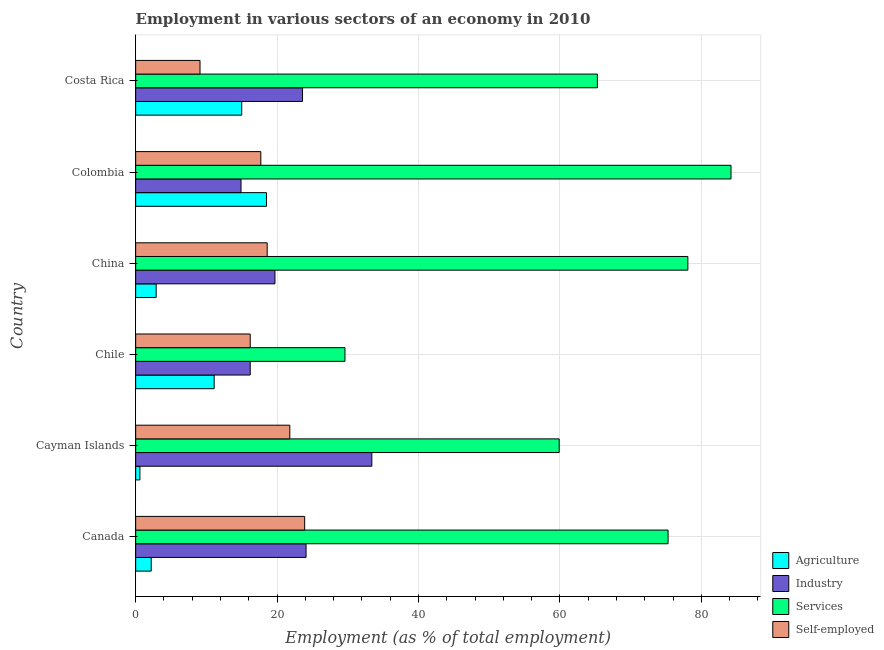How many different coloured bars are there?
Keep it short and to the point. 4. Are the number of bars per tick equal to the number of legend labels?
Provide a short and direct response. Yes. How many bars are there on the 6th tick from the top?
Provide a succinct answer. 4. What is the label of the 1st group of bars from the top?
Your answer should be very brief. Costa Rica. What is the percentage of workers in industry in Chile?
Give a very brief answer. 16.2. Across all countries, what is the maximum percentage of workers in industry?
Your answer should be compact. 33.4. Across all countries, what is the minimum percentage of workers in industry?
Provide a succinct answer. 14.9. In which country was the percentage of workers in services minimum?
Provide a succinct answer. Chile. What is the total percentage of self employed workers in the graph?
Provide a succinct answer. 107.3. What is the difference between the percentage of self employed workers in China and the percentage of workers in agriculture in Canada?
Offer a terse response. 16.4. What is the average percentage of workers in industry per country?
Your response must be concise. 21.98. What is the difference between the percentage of workers in industry and percentage of workers in agriculture in Cayman Islands?
Your answer should be compact. 32.8. What is the ratio of the percentage of self employed workers in China to that in Colombia?
Keep it short and to the point. 1.05. What is the difference between the highest and the lowest percentage of workers in industry?
Ensure brevity in your answer.  18.5. Is it the case that in every country, the sum of the percentage of self employed workers and percentage of workers in industry is greater than the sum of percentage of workers in services and percentage of workers in agriculture?
Offer a very short reply. No. What does the 2nd bar from the top in Canada represents?
Make the answer very short. Services. What does the 2nd bar from the bottom in Colombia represents?
Offer a very short reply. Industry. How many bars are there?
Offer a very short reply. 24. Are all the bars in the graph horizontal?
Your answer should be compact. Yes. What is the difference between two consecutive major ticks on the X-axis?
Your answer should be very brief. 20. Does the graph contain any zero values?
Your answer should be compact. No. Does the graph contain grids?
Offer a very short reply. Yes. What is the title of the graph?
Your answer should be compact. Employment in various sectors of an economy in 2010. Does "Social Awareness" appear as one of the legend labels in the graph?
Ensure brevity in your answer.  No. What is the label or title of the X-axis?
Provide a short and direct response. Employment (as % of total employment). What is the label or title of the Y-axis?
Make the answer very short. Country. What is the Employment (as % of total employment) of Agriculture in Canada?
Offer a very short reply. 2.2. What is the Employment (as % of total employment) in Industry in Canada?
Keep it short and to the point. 24.1. What is the Employment (as % of total employment) of Services in Canada?
Offer a terse response. 75.3. What is the Employment (as % of total employment) of Self-employed in Canada?
Provide a short and direct response. 23.9. What is the Employment (as % of total employment) of Agriculture in Cayman Islands?
Give a very brief answer. 0.6. What is the Employment (as % of total employment) of Industry in Cayman Islands?
Your response must be concise. 33.4. What is the Employment (as % of total employment) in Services in Cayman Islands?
Your answer should be very brief. 59.9. What is the Employment (as % of total employment) in Self-employed in Cayman Islands?
Provide a succinct answer. 21.8. What is the Employment (as % of total employment) of Agriculture in Chile?
Offer a very short reply. 11.1. What is the Employment (as % of total employment) in Industry in Chile?
Make the answer very short. 16.2. What is the Employment (as % of total employment) in Services in Chile?
Keep it short and to the point. 29.6. What is the Employment (as % of total employment) in Self-employed in Chile?
Your answer should be compact. 16.2. What is the Employment (as % of total employment) in Agriculture in China?
Provide a succinct answer. 2.9. What is the Employment (as % of total employment) of Industry in China?
Keep it short and to the point. 19.7. What is the Employment (as % of total employment) of Services in China?
Keep it short and to the point. 78.1. What is the Employment (as % of total employment) in Self-employed in China?
Keep it short and to the point. 18.6. What is the Employment (as % of total employment) of Industry in Colombia?
Offer a very short reply. 14.9. What is the Employment (as % of total employment) of Services in Colombia?
Your answer should be very brief. 84.2. What is the Employment (as % of total employment) of Self-employed in Colombia?
Provide a succinct answer. 17.7. What is the Employment (as % of total employment) of Industry in Costa Rica?
Your response must be concise. 23.6. What is the Employment (as % of total employment) of Services in Costa Rica?
Your response must be concise. 65.3. What is the Employment (as % of total employment) in Self-employed in Costa Rica?
Offer a very short reply. 9.1. Across all countries, what is the maximum Employment (as % of total employment) in Agriculture?
Keep it short and to the point. 18.5. Across all countries, what is the maximum Employment (as % of total employment) in Industry?
Ensure brevity in your answer.  33.4. Across all countries, what is the maximum Employment (as % of total employment) of Services?
Make the answer very short. 84.2. Across all countries, what is the maximum Employment (as % of total employment) of Self-employed?
Your response must be concise. 23.9. Across all countries, what is the minimum Employment (as % of total employment) of Agriculture?
Ensure brevity in your answer.  0.6. Across all countries, what is the minimum Employment (as % of total employment) of Industry?
Provide a succinct answer. 14.9. Across all countries, what is the minimum Employment (as % of total employment) of Services?
Your answer should be very brief. 29.6. Across all countries, what is the minimum Employment (as % of total employment) in Self-employed?
Offer a very short reply. 9.1. What is the total Employment (as % of total employment) of Agriculture in the graph?
Your response must be concise. 50.3. What is the total Employment (as % of total employment) in Industry in the graph?
Keep it short and to the point. 131.9. What is the total Employment (as % of total employment) in Services in the graph?
Provide a short and direct response. 392.4. What is the total Employment (as % of total employment) in Self-employed in the graph?
Provide a short and direct response. 107.3. What is the difference between the Employment (as % of total employment) of Agriculture in Canada and that in Cayman Islands?
Ensure brevity in your answer.  1.6. What is the difference between the Employment (as % of total employment) of Services in Canada and that in Cayman Islands?
Make the answer very short. 15.4. What is the difference between the Employment (as % of total employment) in Industry in Canada and that in Chile?
Your answer should be compact. 7.9. What is the difference between the Employment (as % of total employment) of Services in Canada and that in Chile?
Your answer should be very brief. 45.7. What is the difference between the Employment (as % of total employment) of Self-employed in Canada and that in Chile?
Your answer should be compact. 7.7. What is the difference between the Employment (as % of total employment) of Agriculture in Canada and that in Colombia?
Ensure brevity in your answer.  -16.3. What is the difference between the Employment (as % of total employment) in Agriculture in Canada and that in Costa Rica?
Keep it short and to the point. -12.8. What is the difference between the Employment (as % of total employment) of Industry in Canada and that in Costa Rica?
Your response must be concise. 0.5. What is the difference between the Employment (as % of total employment) of Services in Canada and that in Costa Rica?
Offer a very short reply. 10. What is the difference between the Employment (as % of total employment) of Services in Cayman Islands and that in Chile?
Ensure brevity in your answer.  30.3. What is the difference between the Employment (as % of total employment) in Self-employed in Cayman Islands and that in Chile?
Keep it short and to the point. 5.6. What is the difference between the Employment (as % of total employment) of Services in Cayman Islands and that in China?
Your answer should be compact. -18.2. What is the difference between the Employment (as % of total employment) in Self-employed in Cayman Islands and that in China?
Your response must be concise. 3.2. What is the difference between the Employment (as % of total employment) of Agriculture in Cayman Islands and that in Colombia?
Provide a short and direct response. -17.9. What is the difference between the Employment (as % of total employment) in Services in Cayman Islands and that in Colombia?
Offer a terse response. -24.3. What is the difference between the Employment (as % of total employment) in Self-employed in Cayman Islands and that in Colombia?
Ensure brevity in your answer.  4.1. What is the difference between the Employment (as % of total employment) in Agriculture in Cayman Islands and that in Costa Rica?
Keep it short and to the point. -14.4. What is the difference between the Employment (as % of total employment) in Services in Cayman Islands and that in Costa Rica?
Make the answer very short. -5.4. What is the difference between the Employment (as % of total employment) of Agriculture in Chile and that in China?
Provide a succinct answer. 8.2. What is the difference between the Employment (as % of total employment) of Services in Chile and that in China?
Your answer should be compact. -48.5. What is the difference between the Employment (as % of total employment) in Self-employed in Chile and that in China?
Offer a terse response. -2.4. What is the difference between the Employment (as % of total employment) in Agriculture in Chile and that in Colombia?
Offer a very short reply. -7.4. What is the difference between the Employment (as % of total employment) in Services in Chile and that in Colombia?
Provide a succinct answer. -54.6. What is the difference between the Employment (as % of total employment) of Self-employed in Chile and that in Colombia?
Provide a succinct answer. -1.5. What is the difference between the Employment (as % of total employment) of Agriculture in Chile and that in Costa Rica?
Offer a terse response. -3.9. What is the difference between the Employment (as % of total employment) in Services in Chile and that in Costa Rica?
Offer a very short reply. -35.7. What is the difference between the Employment (as % of total employment) in Agriculture in China and that in Colombia?
Ensure brevity in your answer.  -15.6. What is the difference between the Employment (as % of total employment) of Services in China and that in Colombia?
Ensure brevity in your answer.  -6.1. What is the difference between the Employment (as % of total employment) in Agriculture in China and that in Costa Rica?
Ensure brevity in your answer.  -12.1. What is the difference between the Employment (as % of total employment) in Industry in China and that in Costa Rica?
Offer a terse response. -3.9. What is the difference between the Employment (as % of total employment) in Services in China and that in Costa Rica?
Offer a terse response. 12.8. What is the difference between the Employment (as % of total employment) of Agriculture in Colombia and that in Costa Rica?
Your answer should be very brief. 3.5. What is the difference between the Employment (as % of total employment) of Self-employed in Colombia and that in Costa Rica?
Provide a succinct answer. 8.6. What is the difference between the Employment (as % of total employment) in Agriculture in Canada and the Employment (as % of total employment) in Industry in Cayman Islands?
Offer a very short reply. -31.2. What is the difference between the Employment (as % of total employment) of Agriculture in Canada and the Employment (as % of total employment) of Services in Cayman Islands?
Make the answer very short. -57.7. What is the difference between the Employment (as % of total employment) of Agriculture in Canada and the Employment (as % of total employment) of Self-employed in Cayman Islands?
Provide a succinct answer. -19.6. What is the difference between the Employment (as % of total employment) in Industry in Canada and the Employment (as % of total employment) in Services in Cayman Islands?
Keep it short and to the point. -35.8. What is the difference between the Employment (as % of total employment) of Services in Canada and the Employment (as % of total employment) of Self-employed in Cayman Islands?
Provide a succinct answer. 53.5. What is the difference between the Employment (as % of total employment) in Agriculture in Canada and the Employment (as % of total employment) in Industry in Chile?
Your answer should be very brief. -14. What is the difference between the Employment (as % of total employment) in Agriculture in Canada and the Employment (as % of total employment) in Services in Chile?
Provide a short and direct response. -27.4. What is the difference between the Employment (as % of total employment) of Agriculture in Canada and the Employment (as % of total employment) of Self-employed in Chile?
Keep it short and to the point. -14. What is the difference between the Employment (as % of total employment) in Industry in Canada and the Employment (as % of total employment) in Services in Chile?
Give a very brief answer. -5.5. What is the difference between the Employment (as % of total employment) in Industry in Canada and the Employment (as % of total employment) in Self-employed in Chile?
Ensure brevity in your answer.  7.9. What is the difference between the Employment (as % of total employment) of Services in Canada and the Employment (as % of total employment) of Self-employed in Chile?
Offer a terse response. 59.1. What is the difference between the Employment (as % of total employment) in Agriculture in Canada and the Employment (as % of total employment) in Industry in China?
Your answer should be very brief. -17.5. What is the difference between the Employment (as % of total employment) of Agriculture in Canada and the Employment (as % of total employment) of Services in China?
Offer a terse response. -75.9. What is the difference between the Employment (as % of total employment) in Agriculture in Canada and the Employment (as % of total employment) in Self-employed in China?
Offer a very short reply. -16.4. What is the difference between the Employment (as % of total employment) in Industry in Canada and the Employment (as % of total employment) in Services in China?
Keep it short and to the point. -54. What is the difference between the Employment (as % of total employment) of Industry in Canada and the Employment (as % of total employment) of Self-employed in China?
Your answer should be compact. 5.5. What is the difference between the Employment (as % of total employment) in Services in Canada and the Employment (as % of total employment) in Self-employed in China?
Provide a succinct answer. 56.7. What is the difference between the Employment (as % of total employment) in Agriculture in Canada and the Employment (as % of total employment) in Services in Colombia?
Your answer should be very brief. -82. What is the difference between the Employment (as % of total employment) of Agriculture in Canada and the Employment (as % of total employment) of Self-employed in Colombia?
Give a very brief answer. -15.5. What is the difference between the Employment (as % of total employment) of Industry in Canada and the Employment (as % of total employment) of Services in Colombia?
Ensure brevity in your answer.  -60.1. What is the difference between the Employment (as % of total employment) of Industry in Canada and the Employment (as % of total employment) of Self-employed in Colombia?
Provide a short and direct response. 6.4. What is the difference between the Employment (as % of total employment) of Services in Canada and the Employment (as % of total employment) of Self-employed in Colombia?
Make the answer very short. 57.6. What is the difference between the Employment (as % of total employment) in Agriculture in Canada and the Employment (as % of total employment) in Industry in Costa Rica?
Your response must be concise. -21.4. What is the difference between the Employment (as % of total employment) in Agriculture in Canada and the Employment (as % of total employment) in Services in Costa Rica?
Keep it short and to the point. -63.1. What is the difference between the Employment (as % of total employment) of Industry in Canada and the Employment (as % of total employment) of Services in Costa Rica?
Your answer should be compact. -41.2. What is the difference between the Employment (as % of total employment) of Services in Canada and the Employment (as % of total employment) of Self-employed in Costa Rica?
Offer a terse response. 66.2. What is the difference between the Employment (as % of total employment) of Agriculture in Cayman Islands and the Employment (as % of total employment) of Industry in Chile?
Offer a terse response. -15.6. What is the difference between the Employment (as % of total employment) in Agriculture in Cayman Islands and the Employment (as % of total employment) in Self-employed in Chile?
Offer a terse response. -15.6. What is the difference between the Employment (as % of total employment) of Industry in Cayman Islands and the Employment (as % of total employment) of Self-employed in Chile?
Make the answer very short. 17.2. What is the difference between the Employment (as % of total employment) in Services in Cayman Islands and the Employment (as % of total employment) in Self-employed in Chile?
Ensure brevity in your answer.  43.7. What is the difference between the Employment (as % of total employment) in Agriculture in Cayman Islands and the Employment (as % of total employment) in Industry in China?
Ensure brevity in your answer.  -19.1. What is the difference between the Employment (as % of total employment) of Agriculture in Cayman Islands and the Employment (as % of total employment) of Services in China?
Make the answer very short. -77.5. What is the difference between the Employment (as % of total employment) in Industry in Cayman Islands and the Employment (as % of total employment) in Services in China?
Ensure brevity in your answer.  -44.7. What is the difference between the Employment (as % of total employment) of Industry in Cayman Islands and the Employment (as % of total employment) of Self-employed in China?
Keep it short and to the point. 14.8. What is the difference between the Employment (as % of total employment) of Services in Cayman Islands and the Employment (as % of total employment) of Self-employed in China?
Make the answer very short. 41.3. What is the difference between the Employment (as % of total employment) in Agriculture in Cayman Islands and the Employment (as % of total employment) in Industry in Colombia?
Make the answer very short. -14.3. What is the difference between the Employment (as % of total employment) of Agriculture in Cayman Islands and the Employment (as % of total employment) of Services in Colombia?
Offer a very short reply. -83.6. What is the difference between the Employment (as % of total employment) of Agriculture in Cayman Islands and the Employment (as % of total employment) of Self-employed in Colombia?
Ensure brevity in your answer.  -17.1. What is the difference between the Employment (as % of total employment) of Industry in Cayman Islands and the Employment (as % of total employment) of Services in Colombia?
Your answer should be very brief. -50.8. What is the difference between the Employment (as % of total employment) of Services in Cayman Islands and the Employment (as % of total employment) of Self-employed in Colombia?
Offer a very short reply. 42.2. What is the difference between the Employment (as % of total employment) of Agriculture in Cayman Islands and the Employment (as % of total employment) of Industry in Costa Rica?
Provide a succinct answer. -23. What is the difference between the Employment (as % of total employment) of Agriculture in Cayman Islands and the Employment (as % of total employment) of Services in Costa Rica?
Ensure brevity in your answer.  -64.7. What is the difference between the Employment (as % of total employment) in Industry in Cayman Islands and the Employment (as % of total employment) in Services in Costa Rica?
Ensure brevity in your answer.  -31.9. What is the difference between the Employment (as % of total employment) of Industry in Cayman Islands and the Employment (as % of total employment) of Self-employed in Costa Rica?
Offer a terse response. 24.3. What is the difference between the Employment (as % of total employment) of Services in Cayman Islands and the Employment (as % of total employment) of Self-employed in Costa Rica?
Provide a short and direct response. 50.8. What is the difference between the Employment (as % of total employment) of Agriculture in Chile and the Employment (as % of total employment) of Services in China?
Provide a short and direct response. -67. What is the difference between the Employment (as % of total employment) of Agriculture in Chile and the Employment (as % of total employment) of Self-employed in China?
Your answer should be compact. -7.5. What is the difference between the Employment (as % of total employment) in Industry in Chile and the Employment (as % of total employment) in Services in China?
Provide a succinct answer. -61.9. What is the difference between the Employment (as % of total employment) in Industry in Chile and the Employment (as % of total employment) in Self-employed in China?
Keep it short and to the point. -2.4. What is the difference between the Employment (as % of total employment) in Agriculture in Chile and the Employment (as % of total employment) in Services in Colombia?
Keep it short and to the point. -73.1. What is the difference between the Employment (as % of total employment) of Industry in Chile and the Employment (as % of total employment) of Services in Colombia?
Your answer should be very brief. -68. What is the difference between the Employment (as % of total employment) of Industry in Chile and the Employment (as % of total employment) of Self-employed in Colombia?
Keep it short and to the point. -1.5. What is the difference between the Employment (as % of total employment) of Services in Chile and the Employment (as % of total employment) of Self-employed in Colombia?
Provide a succinct answer. 11.9. What is the difference between the Employment (as % of total employment) in Agriculture in Chile and the Employment (as % of total employment) in Industry in Costa Rica?
Offer a very short reply. -12.5. What is the difference between the Employment (as % of total employment) of Agriculture in Chile and the Employment (as % of total employment) of Services in Costa Rica?
Provide a succinct answer. -54.2. What is the difference between the Employment (as % of total employment) of Industry in Chile and the Employment (as % of total employment) of Services in Costa Rica?
Your response must be concise. -49.1. What is the difference between the Employment (as % of total employment) of Agriculture in China and the Employment (as % of total employment) of Services in Colombia?
Make the answer very short. -81.3. What is the difference between the Employment (as % of total employment) of Agriculture in China and the Employment (as % of total employment) of Self-employed in Colombia?
Keep it short and to the point. -14.8. What is the difference between the Employment (as % of total employment) of Industry in China and the Employment (as % of total employment) of Services in Colombia?
Make the answer very short. -64.5. What is the difference between the Employment (as % of total employment) of Services in China and the Employment (as % of total employment) of Self-employed in Colombia?
Provide a short and direct response. 60.4. What is the difference between the Employment (as % of total employment) of Agriculture in China and the Employment (as % of total employment) of Industry in Costa Rica?
Make the answer very short. -20.7. What is the difference between the Employment (as % of total employment) of Agriculture in China and the Employment (as % of total employment) of Services in Costa Rica?
Your answer should be very brief. -62.4. What is the difference between the Employment (as % of total employment) of Industry in China and the Employment (as % of total employment) of Services in Costa Rica?
Give a very brief answer. -45.6. What is the difference between the Employment (as % of total employment) in Agriculture in Colombia and the Employment (as % of total employment) in Services in Costa Rica?
Your response must be concise. -46.8. What is the difference between the Employment (as % of total employment) of Industry in Colombia and the Employment (as % of total employment) of Services in Costa Rica?
Keep it short and to the point. -50.4. What is the difference between the Employment (as % of total employment) in Services in Colombia and the Employment (as % of total employment) in Self-employed in Costa Rica?
Offer a terse response. 75.1. What is the average Employment (as % of total employment) in Agriculture per country?
Ensure brevity in your answer.  8.38. What is the average Employment (as % of total employment) of Industry per country?
Your answer should be compact. 21.98. What is the average Employment (as % of total employment) in Services per country?
Offer a terse response. 65.4. What is the average Employment (as % of total employment) in Self-employed per country?
Keep it short and to the point. 17.88. What is the difference between the Employment (as % of total employment) of Agriculture and Employment (as % of total employment) of Industry in Canada?
Make the answer very short. -21.9. What is the difference between the Employment (as % of total employment) in Agriculture and Employment (as % of total employment) in Services in Canada?
Make the answer very short. -73.1. What is the difference between the Employment (as % of total employment) in Agriculture and Employment (as % of total employment) in Self-employed in Canada?
Your answer should be compact. -21.7. What is the difference between the Employment (as % of total employment) of Industry and Employment (as % of total employment) of Services in Canada?
Give a very brief answer. -51.2. What is the difference between the Employment (as % of total employment) of Services and Employment (as % of total employment) of Self-employed in Canada?
Your answer should be very brief. 51.4. What is the difference between the Employment (as % of total employment) of Agriculture and Employment (as % of total employment) of Industry in Cayman Islands?
Offer a terse response. -32.8. What is the difference between the Employment (as % of total employment) in Agriculture and Employment (as % of total employment) in Services in Cayman Islands?
Provide a succinct answer. -59.3. What is the difference between the Employment (as % of total employment) of Agriculture and Employment (as % of total employment) of Self-employed in Cayman Islands?
Ensure brevity in your answer.  -21.2. What is the difference between the Employment (as % of total employment) in Industry and Employment (as % of total employment) in Services in Cayman Islands?
Your answer should be very brief. -26.5. What is the difference between the Employment (as % of total employment) in Services and Employment (as % of total employment) in Self-employed in Cayman Islands?
Your answer should be very brief. 38.1. What is the difference between the Employment (as % of total employment) in Agriculture and Employment (as % of total employment) in Industry in Chile?
Give a very brief answer. -5.1. What is the difference between the Employment (as % of total employment) of Agriculture and Employment (as % of total employment) of Services in Chile?
Provide a succinct answer. -18.5. What is the difference between the Employment (as % of total employment) in Industry and Employment (as % of total employment) in Services in Chile?
Your response must be concise. -13.4. What is the difference between the Employment (as % of total employment) in Agriculture and Employment (as % of total employment) in Industry in China?
Your response must be concise. -16.8. What is the difference between the Employment (as % of total employment) in Agriculture and Employment (as % of total employment) in Services in China?
Your answer should be compact. -75.2. What is the difference between the Employment (as % of total employment) in Agriculture and Employment (as % of total employment) in Self-employed in China?
Make the answer very short. -15.7. What is the difference between the Employment (as % of total employment) of Industry and Employment (as % of total employment) of Services in China?
Offer a very short reply. -58.4. What is the difference between the Employment (as % of total employment) of Industry and Employment (as % of total employment) of Self-employed in China?
Give a very brief answer. 1.1. What is the difference between the Employment (as % of total employment) of Services and Employment (as % of total employment) of Self-employed in China?
Keep it short and to the point. 59.5. What is the difference between the Employment (as % of total employment) in Agriculture and Employment (as % of total employment) in Services in Colombia?
Give a very brief answer. -65.7. What is the difference between the Employment (as % of total employment) in Industry and Employment (as % of total employment) in Services in Colombia?
Make the answer very short. -69.3. What is the difference between the Employment (as % of total employment) in Industry and Employment (as % of total employment) in Self-employed in Colombia?
Give a very brief answer. -2.8. What is the difference between the Employment (as % of total employment) of Services and Employment (as % of total employment) of Self-employed in Colombia?
Your answer should be very brief. 66.5. What is the difference between the Employment (as % of total employment) in Agriculture and Employment (as % of total employment) in Services in Costa Rica?
Make the answer very short. -50.3. What is the difference between the Employment (as % of total employment) in Agriculture and Employment (as % of total employment) in Self-employed in Costa Rica?
Provide a short and direct response. 5.9. What is the difference between the Employment (as % of total employment) in Industry and Employment (as % of total employment) in Services in Costa Rica?
Your answer should be compact. -41.7. What is the difference between the Employment (as % of total employment) of Industry and Employment (as % of total employment) of Self-employed in Costa Rica?
Your response must be concise. 14.5. What is the difference between the Employment (as % of total employment) of Services and Employment (as % of total employment) of Self-employed in Costa Rica?
Your answer should be compact. 56.2. What is the ratio of the Employment (as % of total employment) of Agriculture in Canada to that in Cayman Islands?
Provide a succinct answer. 3.67. What is the ratio of the Employment (as % of total employment) in Industry in Canada to that in Cayman Islands?
Provide a short and direct response. 0.72. What is the ratio of the Employment (as % of total employment) in Services in Canada to that in Cayman Islands?
Make the answer very short. 1.26. What is the ratio of the Employment (as % of total employment) in Self-employed in Canada to that in Cayman Islands?
Offer a terse response. 1.1. What is the ratio of the Employment (as % of total employment) in Agriculture in Canada to that in Chile?
Your response must be concise. 0.2. What is the ratio of the Employment (as % of total employment) of Industry in Canada to that in Chile?
Your response must be concise. 1.49. What is the ratio of the Employment (as % of total employment) in Services in Canada to that in Chile?
Provide a succinct answer. 2.54. What is the ratio of the Employment (as % of total employment) in Self-employed in Canada to that in Chile?
Make the answer very short. 1.48. What is the ratio of the Employment (as % of total employment) of Agriculture in Canada to that in China?
Keep it short and to the point. 0.76. What is the ratio of the Employment (as % of total employment) of Industry in Canada to that in China?
Ensure brevity in your answer.  1.22. What is the ratio of the Employment (as % of total employment) of Services in Canada to that in China?
Your answer should be very brief. 0.96. What is the ratio of the Employment (as % of total employment) of Self-employed in Canada to that in China?
Provide a short and direct response. 1.28. What is the ratio of the Employment (as % of total employment) of Agriculture in Canada to that in Colombia?
Offer a very short reply. 0.12. What is the ratio of the Employment (as % of total employment) of Industry in Canada to that in Colombia?
Offer a terse response. 1.62. What is the ratio of the Employment (as % of total employment) of Services in Canada to that in Colombia?
Give a very brief answer. 0.89. What is the ratio of the Employment (as % of total employment) of Self-employed in Canada to that in Colombia?
Your answer should be compact. 1.35. What is the ratio of the Employment (as % of total employment) in Agriculture in Canada to that in Costa Rica?
Make the answer very short. 0.15. What is the ratio of the Employment (as % of total employment) of Industry in Canada to that in Costa Rica?
Your response must be concise. 1.02. What is the ratio of the Employment (as % of total employment) of Services in Canada to that in Costa Rica?
Give a very brief answer. 1.15. What is the ratio of the Employment (as % of total employment) of Self-employed in Canada to that in Costa Rica?
Your answer should be very brief. 2.63. What is the ratio of the Employment (as % of total employment) in Agriculture in Cayman Islands to that in Chile?
Your answer should be very brief. 0.05. What is the ratio of the Employment (as % of total employment) of Industry in Cayman Islands to that in Chile?
Ensure brevity in your answer.  2.06. What is the ratio of the Employment (as % of total employment) in Services in Cayman Islands to that in Chile?
Provide a short and direct response. 2.02. What is the ratio of the Employment (as % of total employment) of Self-employed in Cayman Islands to that in Chile?
Make the answer very short. 1.35. What is the ratio of the Employment (as % of total employment) of Agriculture in Cayman Islands to that in China?
Your response must be concise. 0.21. What is the ratio of the Employment (as % of total employment) of Industry in Cayman Islands to that in China?
Ensure brevity in your answer.  1.7. What is the ratio of the Employment (as % of total employment) in Services in Cayman Islands to that in China?
Give a very brief answer. 0.77. What is the ratio of the Employment (as % of total employment) of Self-employed in Cayman Islands to that in China?
Give a very brief answer. 1.17. What is the ratio of the Employment (as % of total employment) of Agriculture in Cayman Islands to that in Colombia?
Your response must be concise. 0.03. What is the ratio of the Employment (as % of total employment) in Industry in Cayman Islands to that in Colombia?
Provide a succinct answer. 2.24. What is the ratio of the Employment (as % of total employment) of Services in Cayman Islands to that in Colombia?
Keep it short and to the point. 0.71. What is the ratio of the Employment (as % of total employment) in Self-employed in Cayman Islands to that in Colombia?
Ensure brevity in your answer.  1.23. What is the ratio of the Employment (as % of total employment) of Industry in Cayman Islands to that in Costa Rica?
Offer a terse response. 1.42. What is the ratio of the Employment (as % of total employment) of Services in Cayman Islands to that in Costa Rica?
Offer a very short reply. 0.92. What is the ratio of the Employment (as % of total employment) in Self-employed in Cayman Islands to that in Costa Rica?
Make the answer very short. 2.4. What is the ratio of the Employment (as % of total employment) in Agriculture in Chile to that in China?
Provide a succinct answer. 3.83. What is the ratio of the Employment (as % of total employment) of Industry in Chile to that in China?
Provide a succinct answer. 0.82. What is the ratio of the Employment (as % of total employment) of Services in Chile to that in China?
Your answer should be compact. 0.38. What is the ratio of the Employment (as % of total employment) in Self-employed in Chile to that in China?
Make the answer very short. 0.87. What is the ratio of the Employment (as % of total employment) of Industry in Chile to that in Colombia?
Keep it short and to the point. 1.09. What is the ratio of the Employment (as % of total employment) in Services in Chile to that in Colombia?
Offer a terse response. 0.35. What is the ratio of the Employment (as % of total employment) in Self-employed in Chile to that in Colombia?
Give a very brief answer. 0.92. What is the ratio of the Employment (as % of total employment) in Agriculture in Chile to that in Costa Rica?
Provide a short and direct response. 0.74. What is the ratio of the Employment (as % of total employment) of Industry in Chile to that in Costa Rica?
Offer a very short reply. 0.69. What is the ratio of the Employment (as % of total employment) of Services in Chile to that in Costa Rica?
Provide a succinct answer. 0.45. What is the ratio of the Employment (as % of total employment) of Self-employed in Chile to that in Costa Rica?
Your answer should be compact. 1.78. What is the ratio of the Employment (as % of total employment) in Agriculture in China to that in Colombia?
Offer a terse response. 0.16. What is the ratio of the Employment (as % of total employment) of Industry in China to that in Colombia?
Offer a terse response. 1.32. What is the ratio of the Employment (as % of total employment) of Services in China to that in Colombia?
Your answer should be compact. 0.93. What is the ratio of the Employment (as % of total employment) of Self-employed in China to that in Colombia?
Provide a succinct answer. 1.05. What is the ratio of the Employment (as % of total employment) in Agriculture in China to that in Costa Rica?
Give a very brief answer. 0.19. What is the ratio of the Employment (as % of total employment) of Industry in China to that in Costa Rica?
Ensure brevity in your answer.  0.83. What is the ratio of the Employment (as % of total employment) in Services in China to that in Costa Rica?
Offer a terse response. 1.2. What is the ratio of the Employment (as % of total employment) of Self-employed in China to that in Costa Rica?
Offer a terse response. 2.04. What is the ratio of the Employment (as % of total employment) in Agriculture in Colombia to that in Costa Rica?
Offer a terse response. 1.23. What is the ratio of the Employment (as % of total employment) in Industry in Colombia to that in Costa Rica?
Keep it short and to the point. 0.63. What is the ratio of the Employment (as % of total employment) of Services in Colombia to that in Costa Rica?
Give a very brief answer. 1.29. What is the ratio of the Employment (as % of total employment) in Self-employed in Colombia to that in Costa Rica?
Provide a short and direct response. 1.95. What is the difference between the highest and the second highest Employment (as % of total employment) in Services?
Your answer should be very brief. 6.1. What is the difference between the highest and the second highest Employment (as % of total employment) of Self-employed?
Offer a very short reply. 2.1. What is the difference between the highest and the lowest Employment (as % of total employment) of Industry?
Keep it short and to the point. 18.5. What is the difference between the highest and the lowest Employment (as % of total employment) in Services?
Offer a terse response. 54.6. 